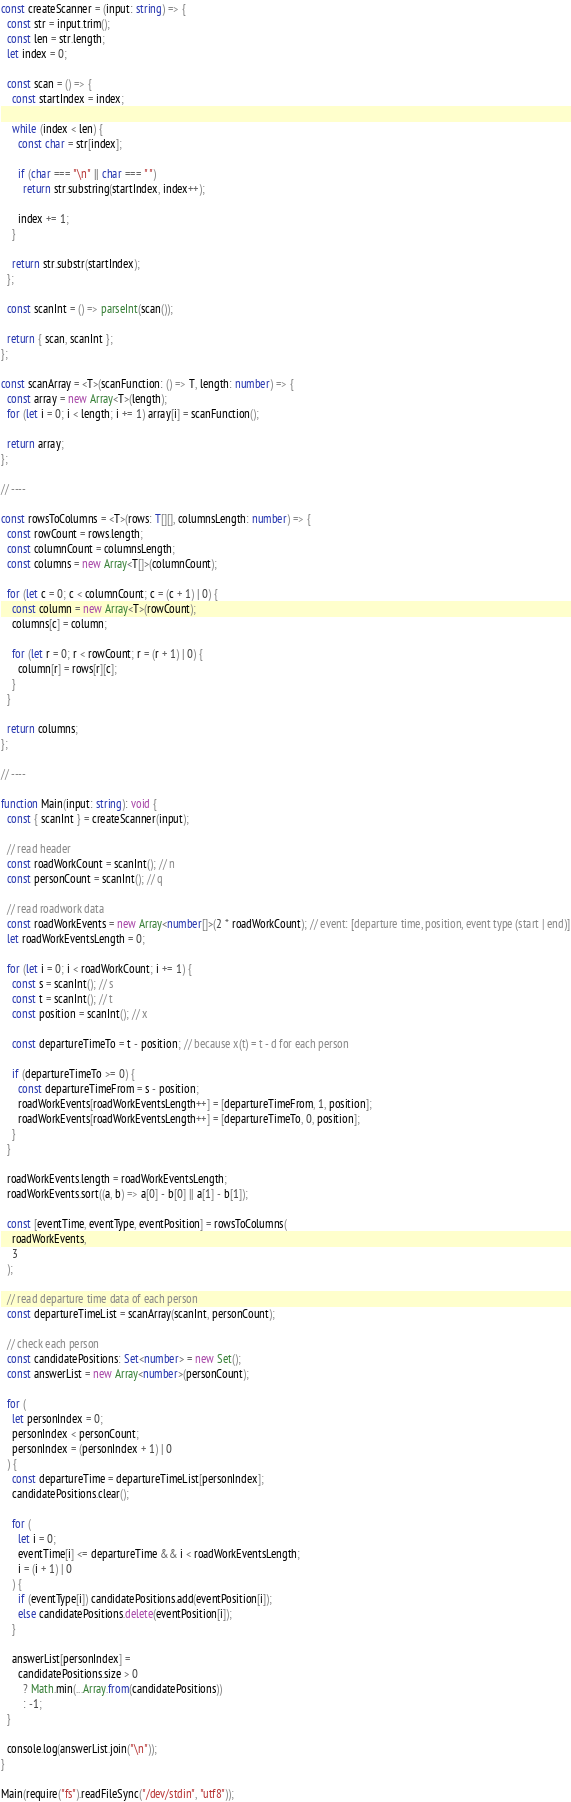Convert code to text. <code><loc_0><loc_0><loc_500><loc_500><_TypeScript_>const createScanner = (input: string) => {
  const str = input.trim();
  const len = str.length;
  let index = 0;

  const scan = () => {
    const startIndex = index;

    while (index < len) {
      const char = str[index];

      if (char === "\n" || char === " ")
        return str.substring(startIndex, index++);

      index += 1;
    }

    return str.substr(startIndex);
  };

  const scanInt = () => parseInt(scan());

  return { scan, scanInt };
};

const scanArray = <T>(scanFunction: () => T, length: number) => {
  const array = new Array<T>(length);
  for (let i = 0; i < length; i += 1) array[i] = scanFunction();

  return array;
};

// ----

const rowsToColumns = <T>(rows: T[][], columnsLength: number) => {
  const rowCount = rows.length;
  const columnCount = columnsLength;
  const columns = new Array<T[]>(columnCount);

  for (let c = 0; c < columnCount; c = (c + 1) | 0) {
    const column = new Array<T>(rowCount);
    columns[c] = column;

    for (let r = 0; r < rowCount; r = (r + 1) | 0) {
      column[r] = rows[r][c];
    }
  }

  return columns;
};

// ----

function Main(input: string): void {
  const { scanInt } = createScanner(input);

  // read header
  const roadWorkCount = scanInt(); // n
  const personCount = scanInt(); // q

  // read roadwork data
  const roadWorkEvents = new Array<number[]>(2 * roadWorkCount); // event: [departure time, position, event type (start | end)]
  let roadWorkEventsLength = 0;

  for (let i = 0; i < roadWorkCount; i += 1) {
    const s = scanInt(); // s
    const t = scanInt(); // t
    const position = scanInt(); // x

    const departureTimeTo = t - position; // because x(t) = t - d for each person

    if (departureTimeTo >= 0) {
      const departureTimeFrom = s - position;
      roadWorkEvents[roadWorkEventsLength++] = [departureTimeFrom, 1, position];
      roadWorkEvents[roadWorkEventsLength++] = [departureTimeTo, 0, position];
    }
  }

  roadWorkEvents.length = roadWorkEventsLength;
  roadWorkEvents.sort((a, b) => a[0] - b[0] || a[1] - b[1]);

  const [eventTime, eventType, eventPosition] = rowsToColumns(
    roadWorkEvents,
    3
  );

  // read departure time data of each person
  const departureTimeList = scanArray(scanInt, personCount);

  // check each person
  const candidatePositions: Set<number> = new Set();
  const answerList = new Array<number>(personCount);

  for (
    let personIndex = 0;
    personIndex < personCount;
    personIndex = (personIndex + 1) | 0
  ) {
    const departureTime = departureTimeList[personIndex];
    candidatePositions.clear();

    for (
      let i = 0;
      eventTime[i] <= departureTime && i < roadWorkEventsLength;
      i = (i + 1) | 0
    ) {
      if (eventType[i]) candidatePositions.add(eventPosition[i]);
      else candidatePositions.delete(eventPosition[i]);
    }

    answerList[personIndex] =
      candidatePositions.size > 0
        ? Math.min(...Array.from(candidatePositions))
        : -1;
  }

  console.log(answerList.join("\n"));
}

Main(require("fs").readFileSync("/dev/stdin", "utf8"));
</code> 